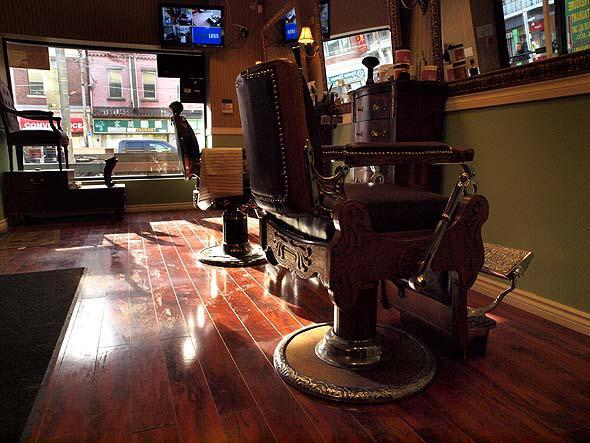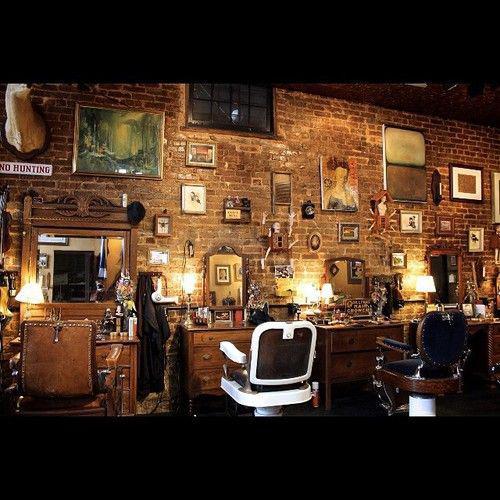The first image is the image on the left, the second image is the image on the right. For the images shown, is this caption "There are no people visible in the images." true? Answer yes or no. Yes. The first image is the image on the left, the second image is the image on the right. Assess this claim about the two images: "there are people in the image on the left". Correct or not? Answer yes or no. No. 